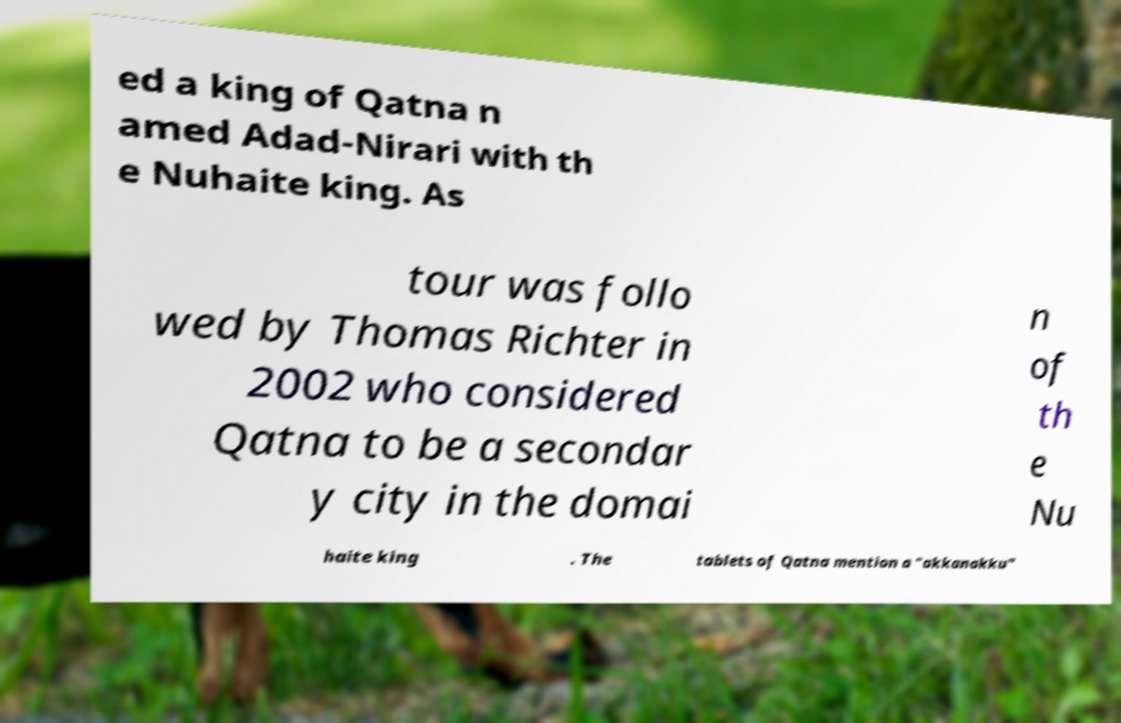There's text embedded in this image that I need extracted. Can you transcribe it verbatim? ed a king of Qatna n amed Adad-Nirari with th e Nuhaite king. As tour was follo wed by Thomas Richter in 2002 who considered Qatna to be a secondar y city in the domai n of th e Nu haite king . The tablets of Qatna mention a "akkanakku" 